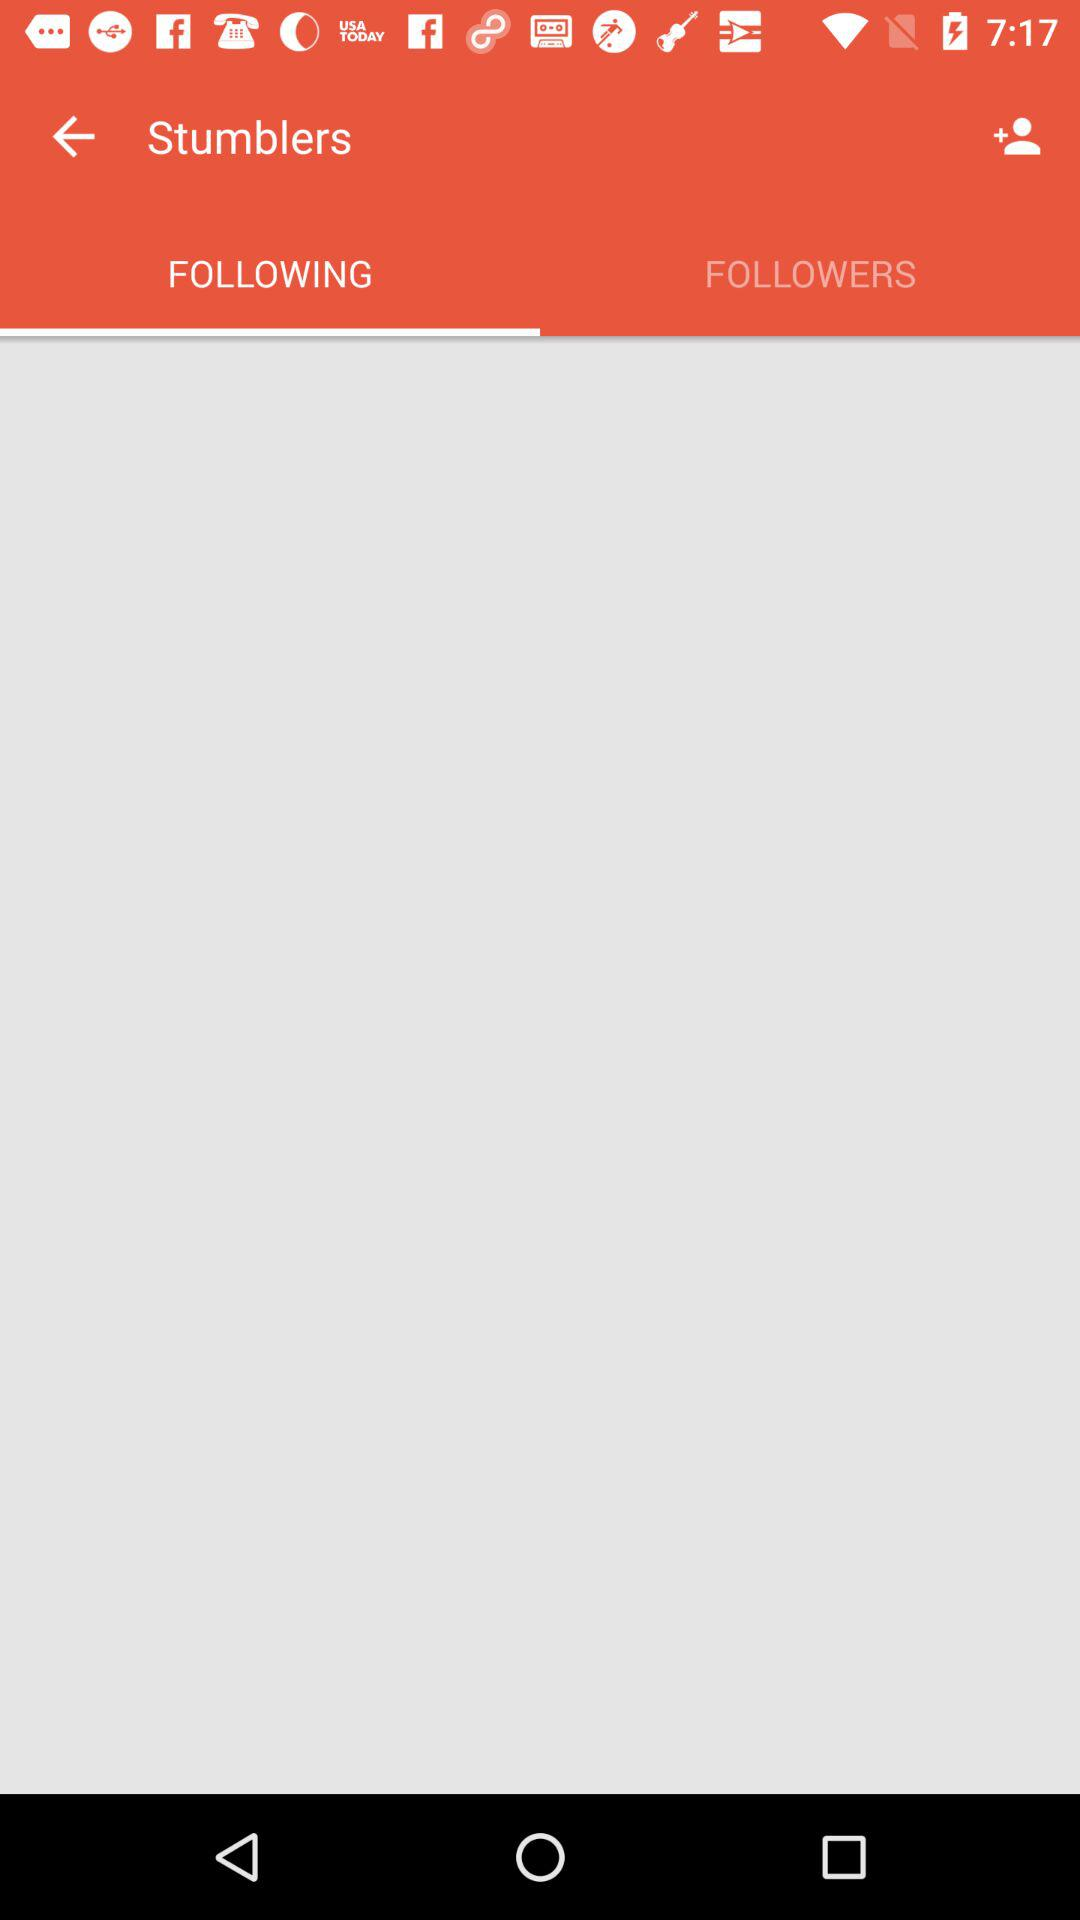How many are following?
When the provided information is insufficient, respond with <no answer>. <no answer> 